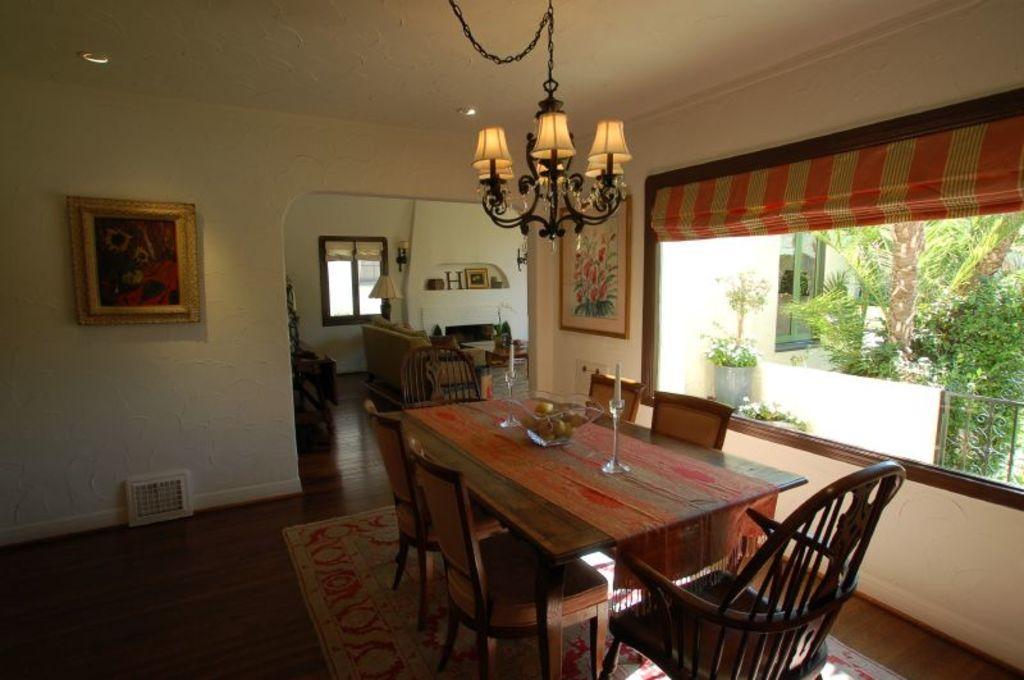In one or two sentences, can you explain what this image depicts? On the right side of the image there is a window with curtains. Behind the window there are trees, plant and also there is wall with railing. On the left side of the image there is a wall with frame. In front of the window there is a table with bowl, stands with candles and also there are chairs. On the floor there is floor mat. In the background there are sofa chairs, table and wall with windows, lamps and some other things. At the top of the image there is chandelier. 